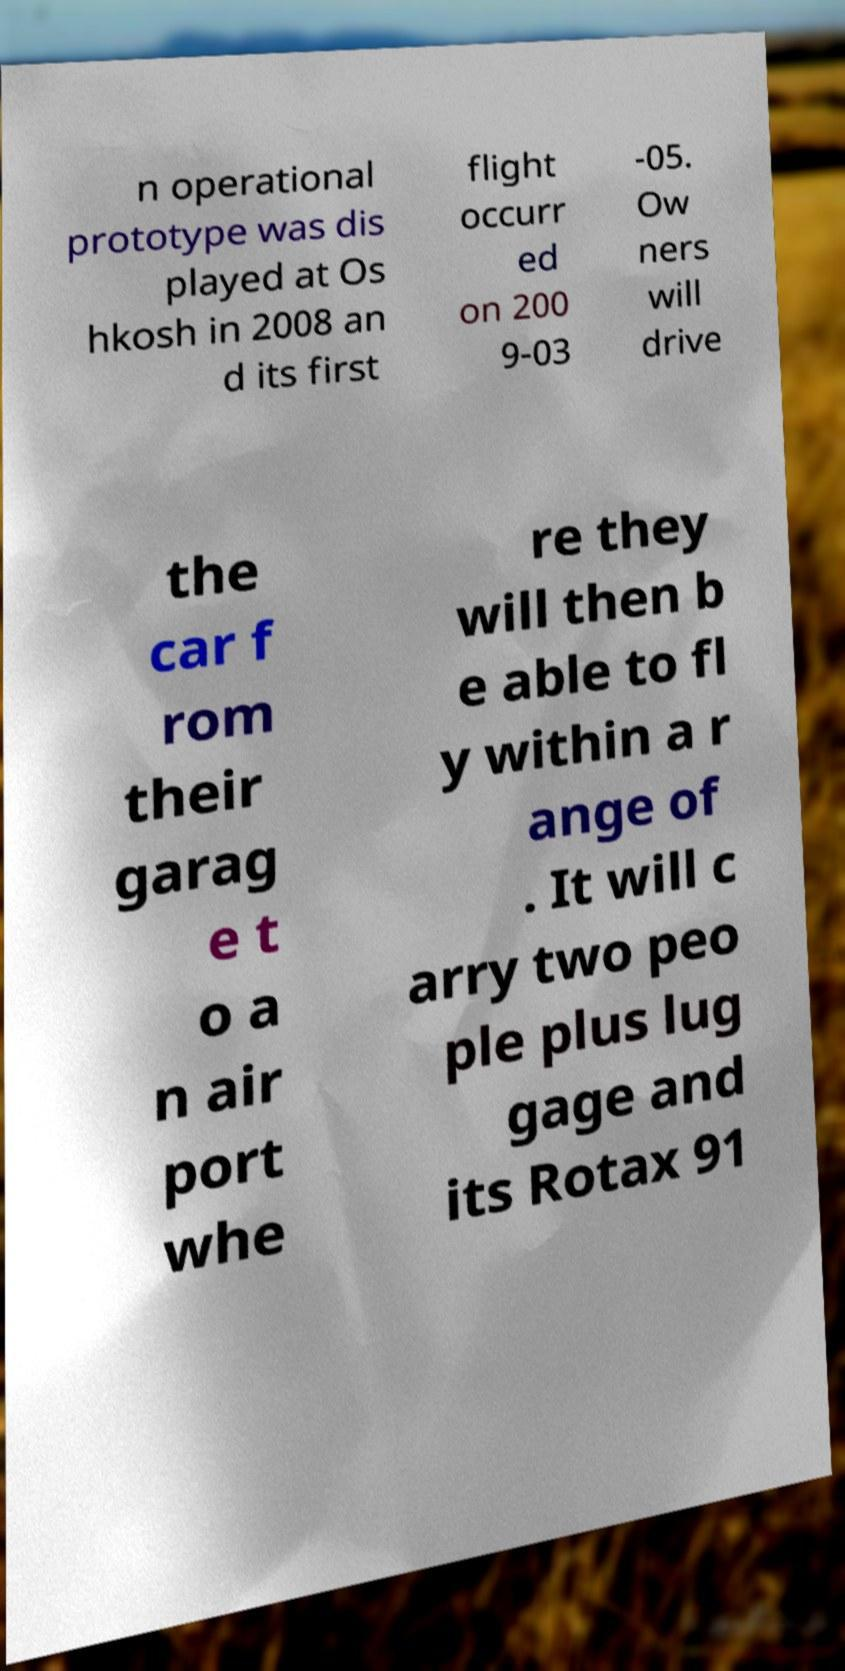I need the written content from this picture converted into text. Can you do that? n operational prototype was dis played at Os hkosh in 2008 an d its first flight occurr ed on 200 9-03 -05. Ow ners will drive the car f rom their garag e t o a n air port whe re they will then b e able to fl y within a r ange of . It will c arry two peo ple plus lug gage and its Rotax 91 